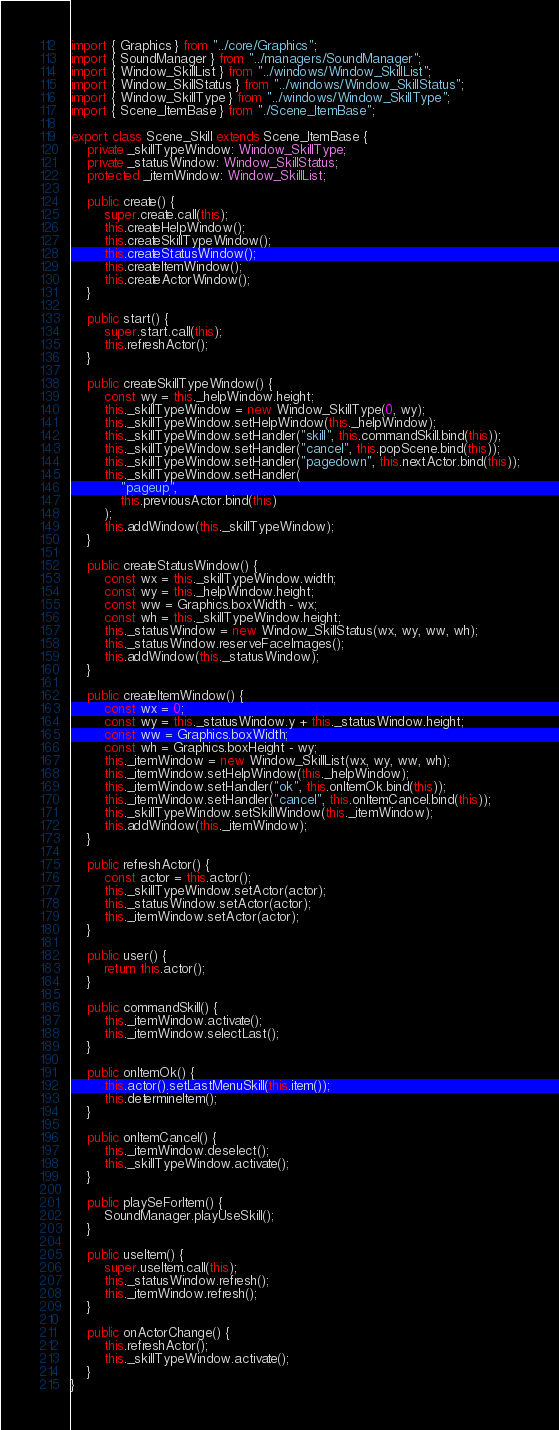<code> <loc_0><loc_0><loc_500><loc_500><_TypeScript_>import { Graphics } from "../core/Graphics";
import { SoundManager } from "../managers/SoundManager";
import { Window_SkillList } from "../windows/Window_SkillList";
import { Window_SkillStatus } from "../windows/Window_SkillStatus";
import { Window_SkillType } from "../windows/Window_SkillType";
import { Scene_ItemBase } from "./Scene_ItemBase";

export class Scene_Skill extends Scene_ItemBase {
    private _skillTypeWindow: Window_SkillType;
    private _statusWindow: Window_SkillStatus;
    protected _itemWindow: Window_SkillList;

    public create() {
        super.create.call(this);
        this.createHelpWindow();
        this.createSkillTypeWindow();
        this.createStatusWindow();
        this.createItemWindow();
        this.createActorWindow();
    }

    public start() {
        super.start.call(this);
        this.refreshActor();
    }

    public createSkillTypeWindow() {
        const wy = this._helpWindow.height;
        this._skillTypeWindow = new Window_SkillType(0, wy);
        this._skillTypeWindow.setHelpWindow(this._helpWindow);
        this._skillTypeWindow.setHandler("skill", this.commandSkill.bind(this));
        this._skillTypeWindow.setHandler("cancel", this.popScene.bind(this));
        this._skillTypeWindow.setHandler("pagedown", this.nextActor.bind(this));
        this._skillTypeWindow.setHandler(
            "pageup",
            this.previousActor.bind(this)
        );
        this.addWindow(this._skillTypeWindow);
    }

    public createStatusWindow() {
        const wx = this._skillTypeWindow.width;
        const wy = this._helpWindow.height;
        const ww = Graphics.boxWidth - wx;
        const wh = this._skillTypeWindow.height;
        this._statusWindow = new Window_SkillStatus(wx, wy, ww, wh);
        this._statusWindow.reserveFaceImages();
        this.addWindow(this._statusWindow);
    }

    public createItemWindow() {
        const wx = 0;
        const wy = this._statusWindow.y + this._statusWindow.height;
        const ww = Graphics.boxWidth;
        const wh = Graphics.boxHeight - wy;
        this._itemWindow = new Window_SkillList(wx, wy, ww, wh);
        this._itemWindow.setHelpWindow(this._helpWindow);
        this._itemWindow.setHandler("ok", this.onItemOk.bind(this));
        this._itemWindow.setHandler("cancel", this.onItemCancel.bind(this));
        this._skillTypeWindow.setSkillWindow(this._itemWindow);
        this.addWindow(this._itemWindow);
    }

    public refreshActor() {
        const actor = this.actor();
        this._skillTypeWindow.setActor(actor);
        this._statusWindow.setActor(actor);
        this._itemWindow.setActor(actor);
    }

    public user() {
        return this.actor();
    }

    public commandSkill() {
        this._itemWindow.activate();
        this._itemWindow.selectLast();
    }

    public onItemOk() {
        this.actor().setLastMenuSkill(this.item());
        this.determineItem();
    }

    public onItemCancel() {
        this._itemWindow.deselect();
        this._skillTypeWindow.activate();
    }

    public playSeForItem() {
        SoundManager.playUseSkill();
    }

    public useItem() {
        super.useItem.call(this);
        this._statusWindow.refresh();
        this._itemWindow.refresh();
    }

    public onActorChange() {
        this.refreshActor();
        this._skillTypeWindow.activate();
    }
}
</code> 